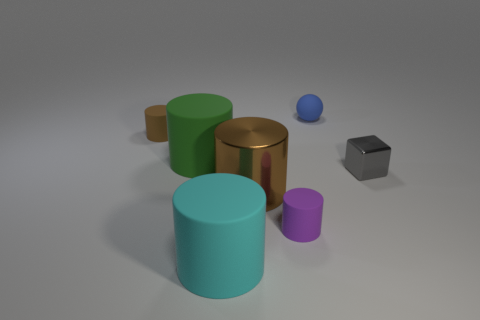The sphere that is made of the same material as the green cylinder is what color? blue 